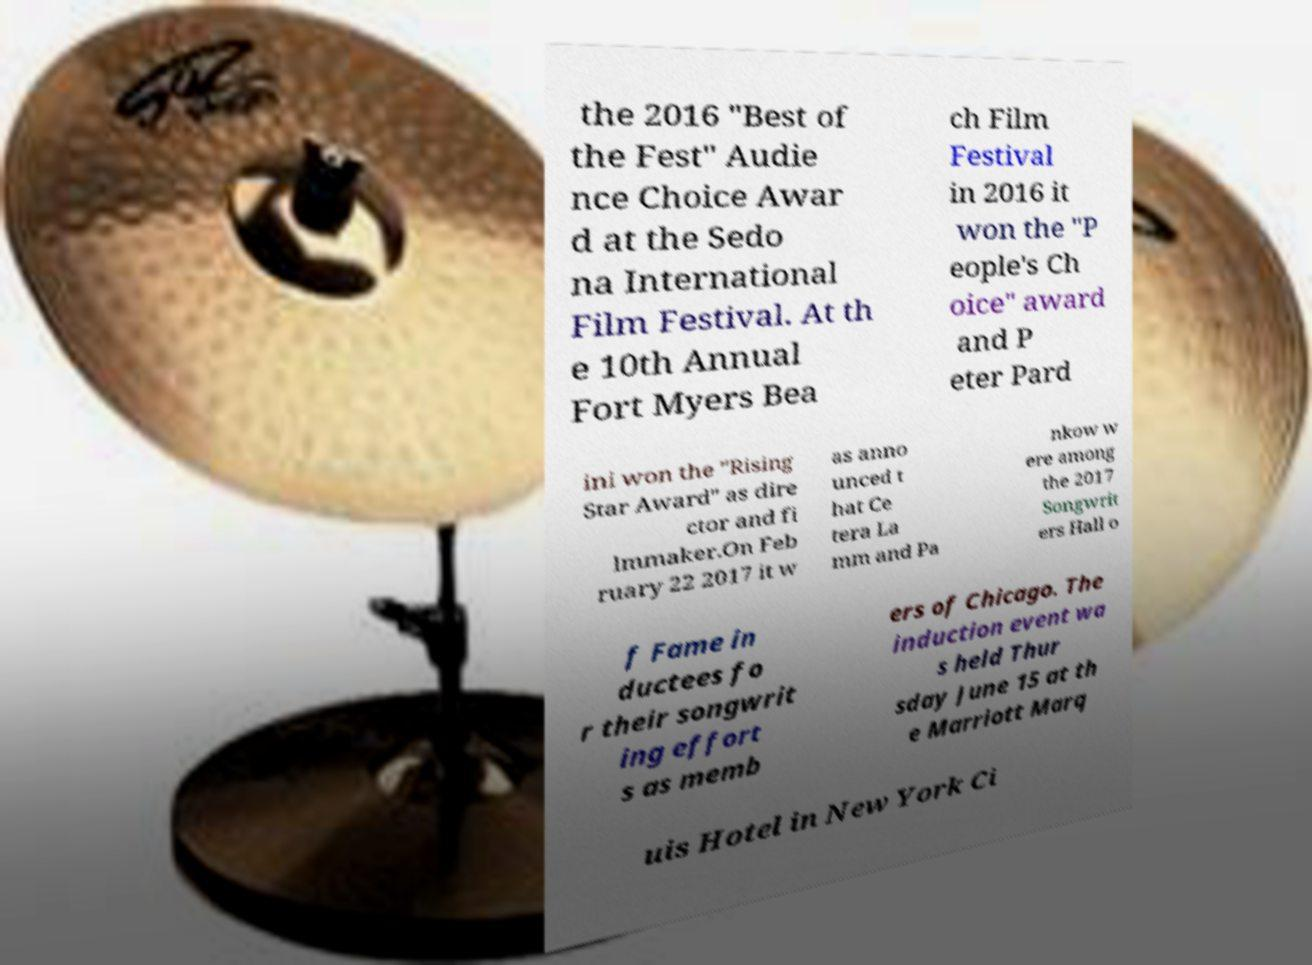Could you assist in decoding the text presented in this image and type it out clearly? the 2016 "Best of the Fest" Audie nce Choice Awar d at the Sedo na International Film Festival. At th e 10th Annual Fort Myers Bea ch Film Festival in 2016 it won the "P eople's Ch oice" award and P eter Pard ini won the "Rising Star Award" as dire ctor and fi lmmaker.On Feb ruary 22 2017 it w as anno unced t hat Ce tera La mm and Pa nkow w ere among the 2017 Songwrit ers Hall o f Fame in ductees fo r their songwrit ing effort s as memb ers of Chicago. The induction event wa s held Thur sday June 15 at th e Marriott Marq uis Hotel in New York Ci 